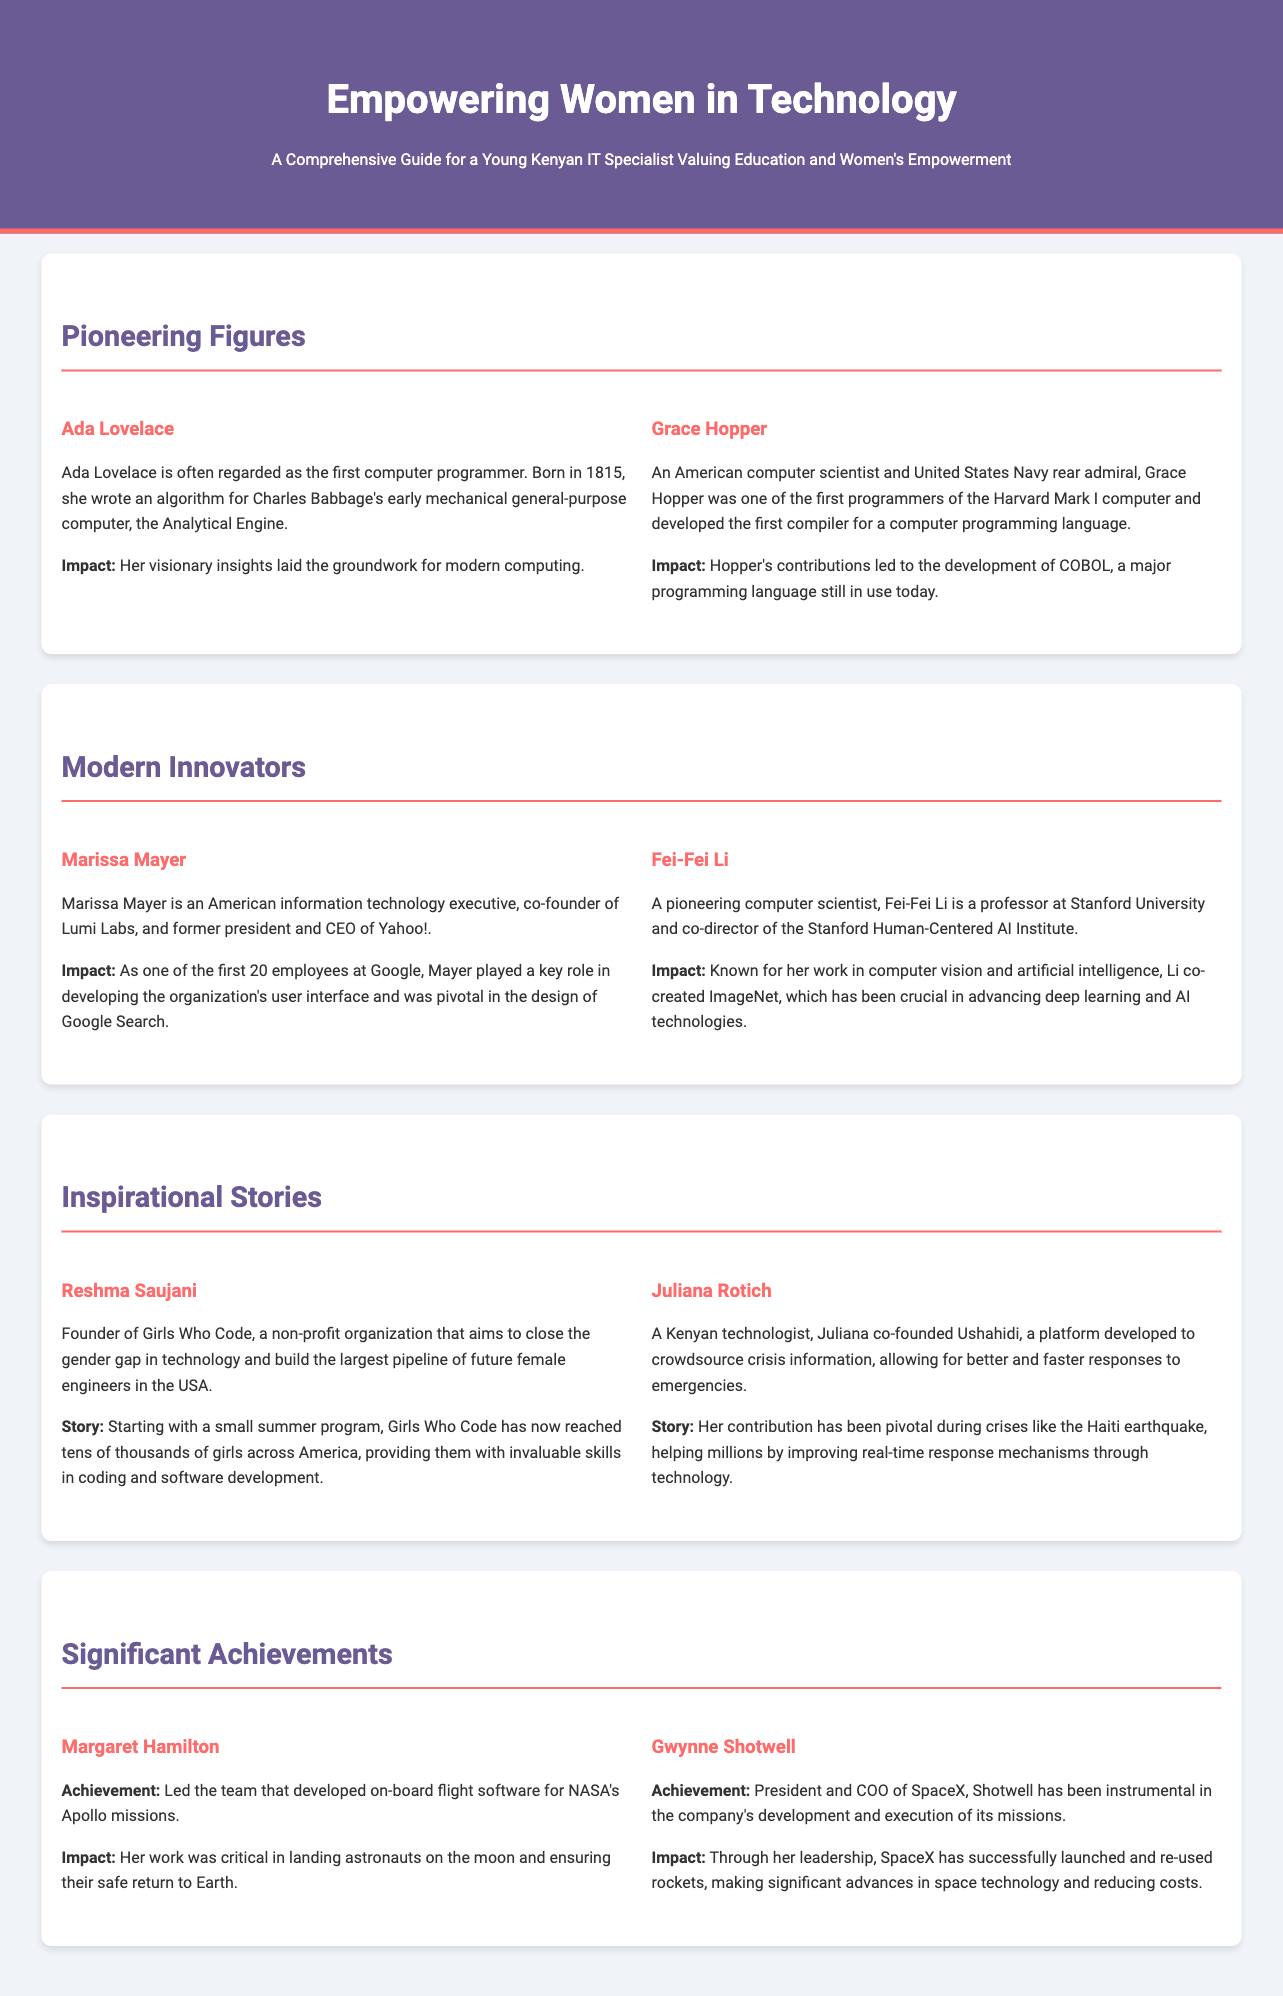What is the title of the document? The title of the document is clearly displayed in the header section as "Empowering Women in Technology."
Answer: Empowering Women in Technology Who is regarded as the first computer programmer? The document mentions Ada Lovelace as often being regarded as the first computer programmer.
Answer: Ada Lovelace What organization did Reshma Saujani found? According to the document, Reshma Saujani is the founder of Girls Who Code.
Answer: Girls Who Code What is the impact of Grace Hopper's contributions? The document states that Grace Hopper's contributions led to the development of COBOL, a major programming language.
Answer: COBOL How many profiles are listed under "Modern Innovators"? The document lists two profiles under "Modern Innovators," which are Marissa Mayer and Fei-Fei Li.
Answer: 2 What significant achievement is Margaret Hamilton known for? The document highlights that Margaret Hamilton led the team that developed on-board flight software for NASA's Apollo missions.
Answer: On-board flight software for NASA's Apollo missions What is the primary focus of the document? The document serves as a comprehensive guide highlighting the contributions of women in technology.
Answer: Contributions of women in technology What is Marissa Mayer known for in technology? According to the document, Marissa Mayer played a key role in developing the organization's user interface at Google.
Answer: Developing the user interface at Google Who co-founded Ushahidi? Juliana Rotich is mentioned in the document as the co-founder of Ushahidi.
Answer: Juliana Rotich 